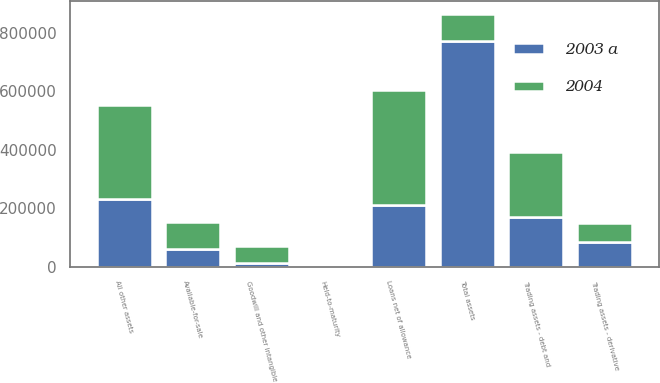Convert chart to OTSL. <chart><loc_0><loc_0><loc_500><loc_500><stacked_bar_chart><ecel><fcel>Trading assets - debt and<fcel>Trading assets - derivative<fcel>Available-for-sale<fcel>Held-to-maturity<fcel>Loans net of allowance<fcel>Goodwill and other intangible<fcel>All other assets<fcel>Total assets<nl><fcel>2004<fcel>222832<fcel>65982<fcel>94402<fcel>110<fcel>394794<fcel>57887<fcel>321241<fcel>94402<nl><fcel>2003 a<fcel>169120<fcel>83751<fcel>60068<fcel>176<fcel>210243<fcel>14991<fcel>232563<fcel>770912<nl></chart> 